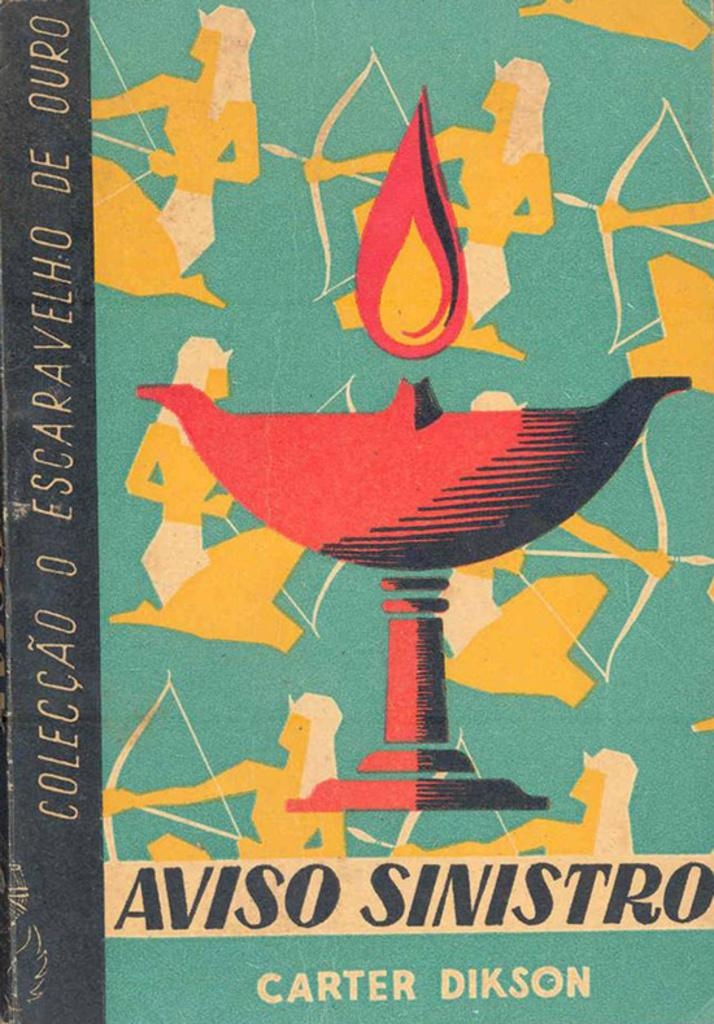<image>
Offer a succinct explanation of the picture presented. a book called Aviso Sinistron by Carter Dikson 